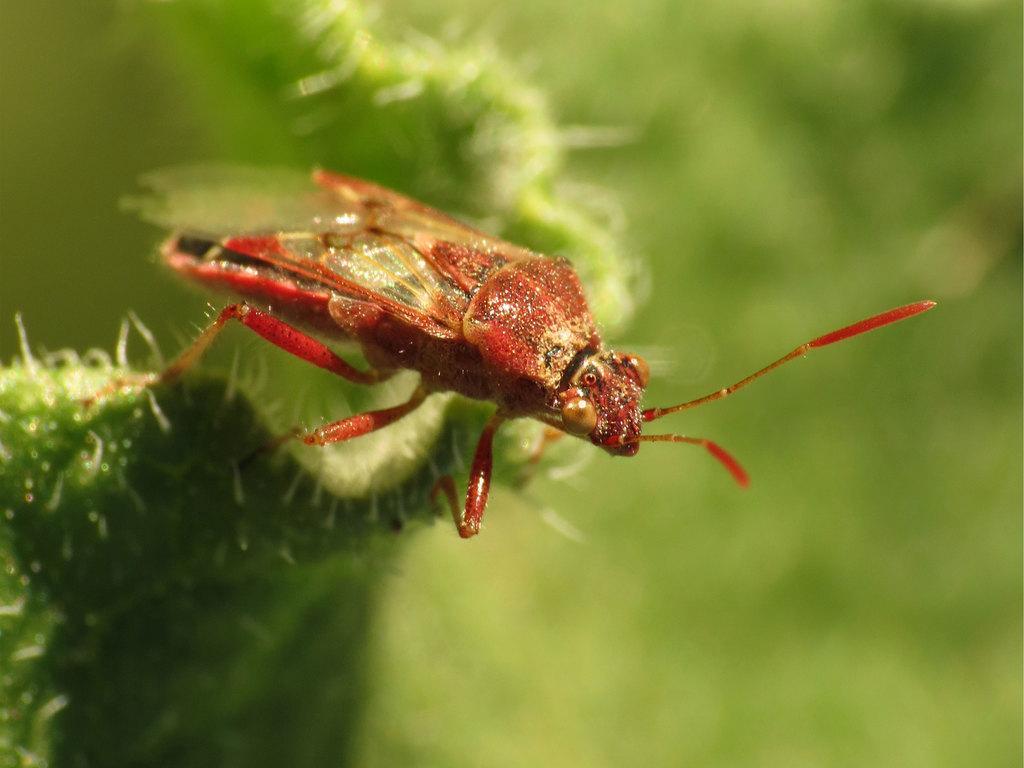In one or two sentences, can you explain what this image depicts? In this image I can see an insect which is in red and brown color. It is on the plant. I can see the blurred background. 